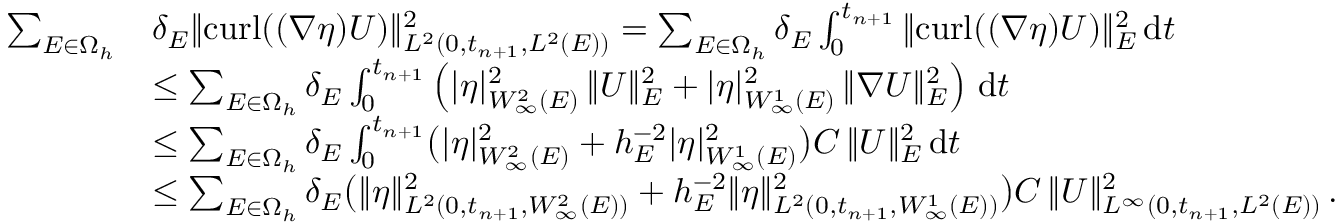Convert formula to latex. <formula><loc_0><loc_0><loc_500><loc_500>\begin{array} { r l } { \sum _ { E \in \Omega _ { h } } } & { \delta _ { E } \| { c u r l } ( ( \nabla \eta ) U ) \| _ { L ^ { 2 } ( 0 , t _ { n + 1 } , L ^ { 2 } ( E ) ) } ^ { 2 } = \sum _ { E \in \Omega _ { h } } \delta _ { E } \int _ { 0 } ^ { t _ { n + 1 } } \| { c u r l } ( ( \nabla \eta ) U ) \| _ { E } ^ { 2 } \, d t } \\ & { \leq \sum _ { E \in \Omega _ { h } } \delta _ { E } \int _ { 0 } ^ { t _ { n + 1 } } \left ( | \eta | _ { W _ { \infty } ^ { 2 } ( E ) } ^ { 2 } \, \| U \| _ { E } ^ { 2 } + | \eta | _ { W _ { \infty } ^ { 1 } ( E ) } ^ { 2 } \, \| \nabla U \| _ { E } ^ { 2 } \right ) \, d t } \\ & { \leq \sum _ { E \in \Omega _ { h } } \delta _ { E } \int _ { 0 } ^ { t _ { n + 1 } } \left ( | \eta | _ { W _ { \infty } ^ { 2 } ( E ) } ^ { 2 } + h _ { E } ^ { - 2 } | \eta | _ { W _ { \infty } ^ { 1 } ( E ) } ^ { 2 } \right ) C \, \| U \| _ { E } ^ { 2 } \, d t } \\ & { \leq \sum _ { E \in \Omega _ { h } } \delta _ { E } \left ( \| \eta \| _ { L ^ { 2 } ( 0 , t _ { n + 1 } , W _ { \infty } ^ { 2 } ( E ) ) } ^ { 2 } + h _ { E } ^ { - 2 } \| \eta \| _ { L ^ { 2 } ( 0 , t _ { n + 1 } , W _ { \infty } ^ { 1 } ( E ) ) } ^ { 2 } \right ) C \, \| U \| _ { L ^ { \infty } ( 0 , t _ { n + 1 } , L ^ { 2 } ( E ) ) } ^ { 2 } \, . } \end{array}</formula> 